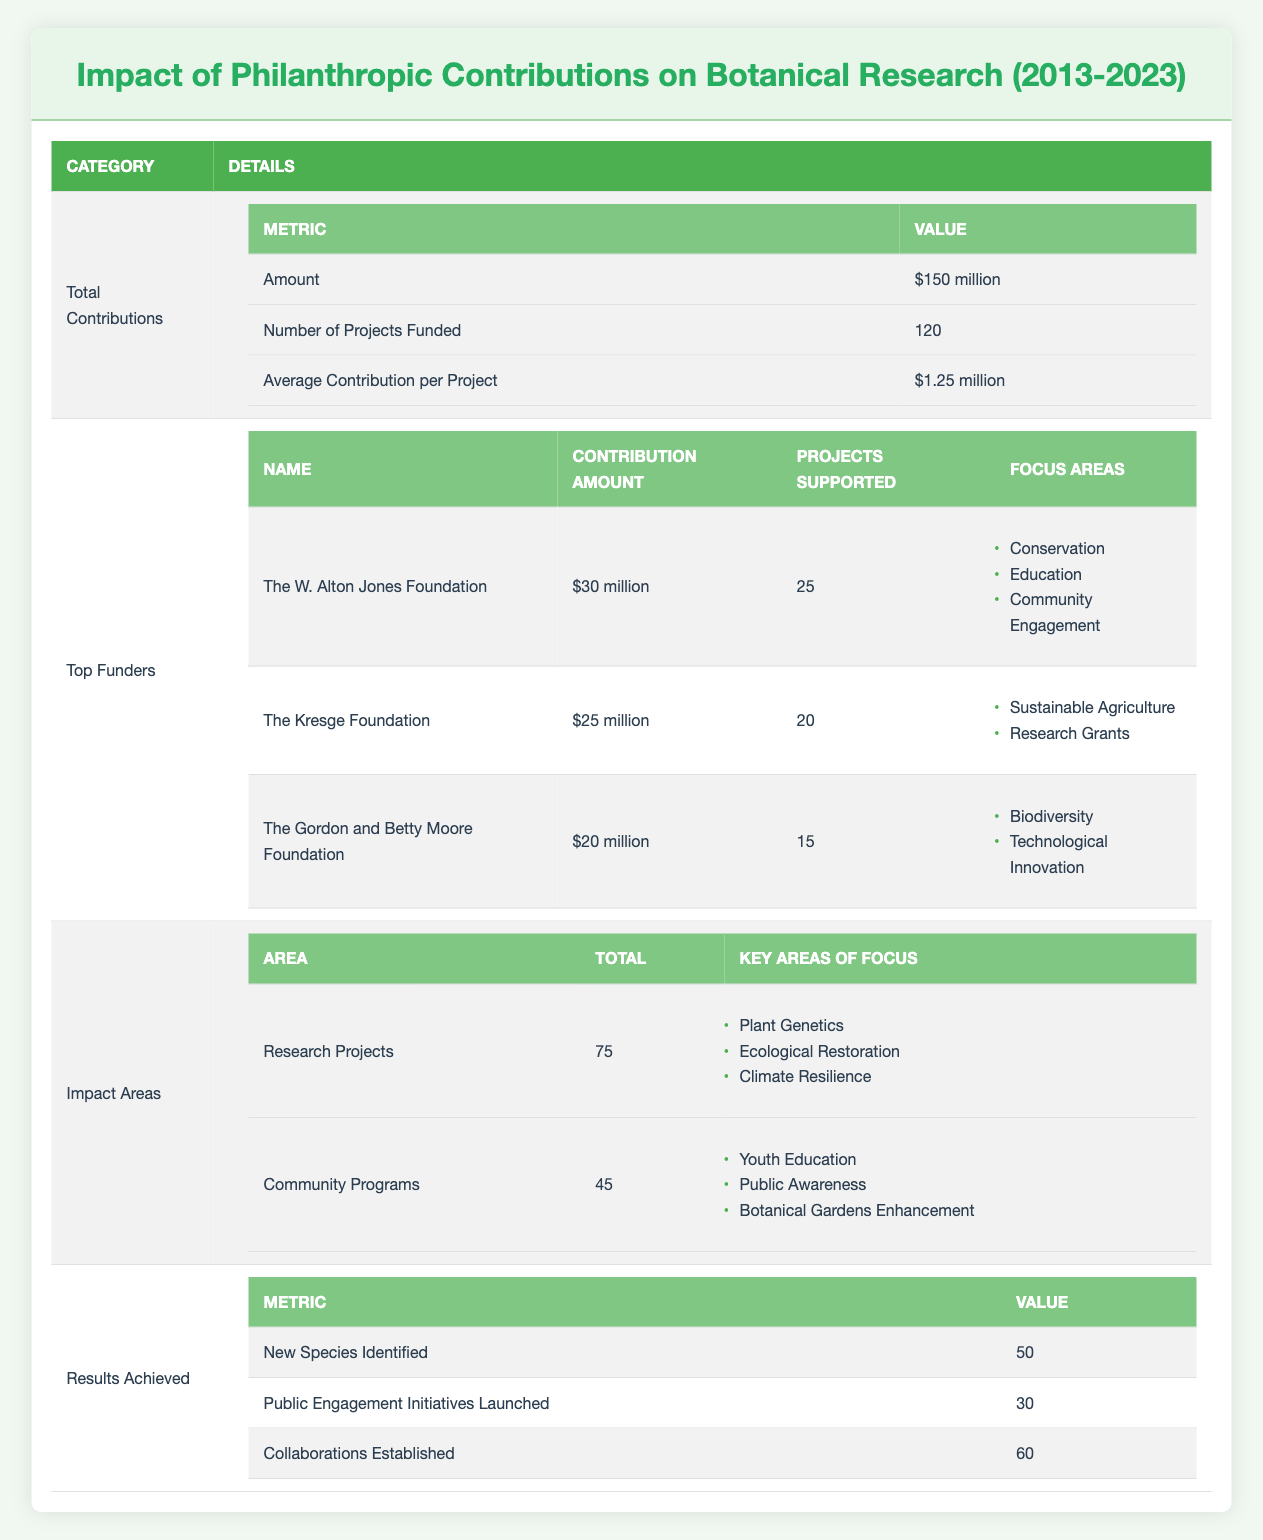What is the total amount of philanthropic contributions between 2013 and 2023? The table clearly states that the total contributions from 2013 to 2023 amounted to $150 million.
Answer: $150 million How many projects were funded in total from the contributions? According to the table, there were 120 projects funded by the philanthropic contributions.
Answer: 120 Who is the top funder, and how much did they contribute? The table lists "The W. Alton Jones Foundation" as the top funder with a contribution amount of $30 million.
Answer: The W. Alton Jones Foundation; $30 million What are the key focus areas supported by The Kresge Foundation? The Kresge Foundation's focus areas as outlined in the table are Sustainable Agriculture and Research Grants.
Answer: Sustainable Agriculture, Research Grants What is the average contribution amount per project? The average contribution is calculated by dividing the total contributions by the number of projects funded: $150 million / 120 = $1.25 million.
Answer: $1.25 million Is the total number of community programs greater than the total number of research projects? The table shows 45 community programs and 75 research projects; thus, the number of community programs is not greater.
Answer: No How many new species were identified as a result of these contributions? The table indicates that 50 new species were identified.
Answer: 50 What is the total number of engagement initiatives launched and collaborations established? The total of public engagement initiatives launched is 30 and collaborations established is 60, so combined they total 90 initiatives.
Answer: 90 If we compare the amount contributed by the top three funders, what is their combined contribution? The contributions are $30 million (The W. Alton Jones Foundation), $25 million (The Kresge Foundation), and $20 million (The Gordon and Betty Moore Foundation). Summing them gives: $30 million + $25 million + $20 million = $75 million.
Answer: $75 million What percentage of the total contributions was made by the Gordon and Betty Moore Foundation? The Gordon and Betty Moore Foundation contributed $20 million, so the percentage is calculated as ($20 million / $150 million) * 100 = 13.33%.
Answer: 13.33% 